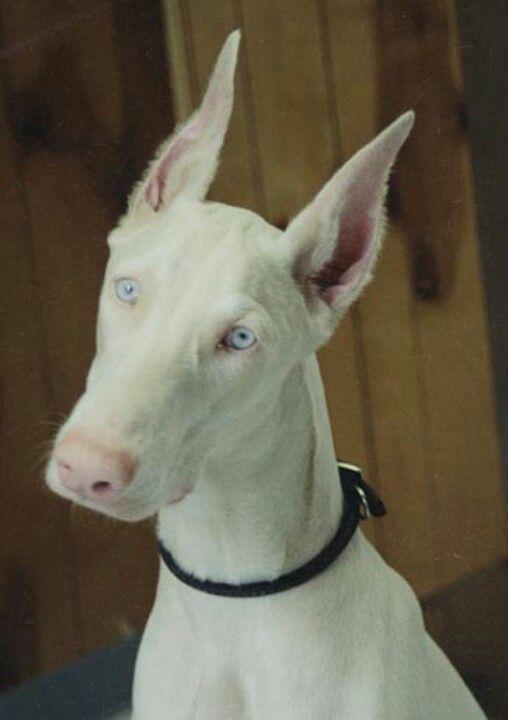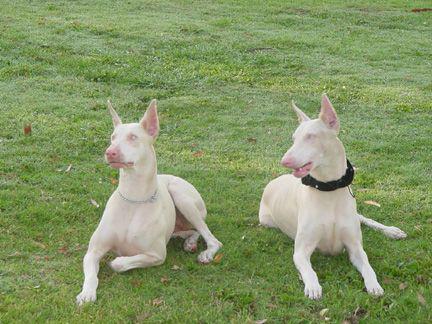The first image is the image on the left, the second image is the image on the right. Analyze the images presented: Is the assertion "At least one dog is laying down." valid? Answer yes or no. Yes. The first image is the image on the left, the second image is the image on the right. Assess this claim about the two images: "Three or more dogs are visible.". Correct or not? Answer yes or no. Yes. 